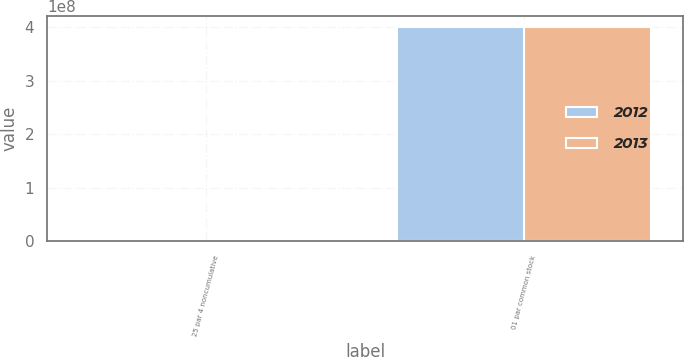Convert chart to OTSL. <chart><loc_0><loc_0><loc_500><loc_500><stacked_bar_chart><ecel><fcel>25 par 4 noncumulative<fcel>01 par common stock<nl><fcel>2012<fcel>840000<fcel>4e+08<nl><fcel>2013<fcel>840000<fcel>4e+08<nl></chart> 